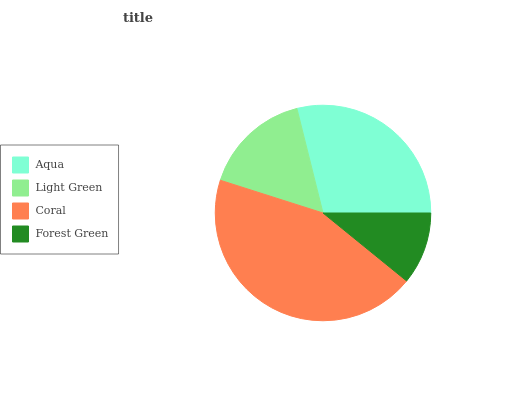Is Forest Green the minimum?
Answer yes or no. Yes. Is Coral the maximum?
Answer yes or no. Yes. Is Light Green the minimum?
Answer yes or no. No. Is Light Green the maximum?
Answer yes or no. No. Is Aqua greater than Light Green?
Answer yes or no. Yes. Is Light Green less than Aqua?
Answer yes or no. Yes. Is Light Green greater than Aqua?
Answer yes or no. No. Is Aqua less than Light Green?
Answer yes or no. No. Is Aqua the high median?
Answer yes or no. Yes. Is Light Green the low median?
Answer yes or no. Yes. Is Light Green the high median?
Answer yes or no. No. Is Forest Green the low median?
Answer yes or no. No. 